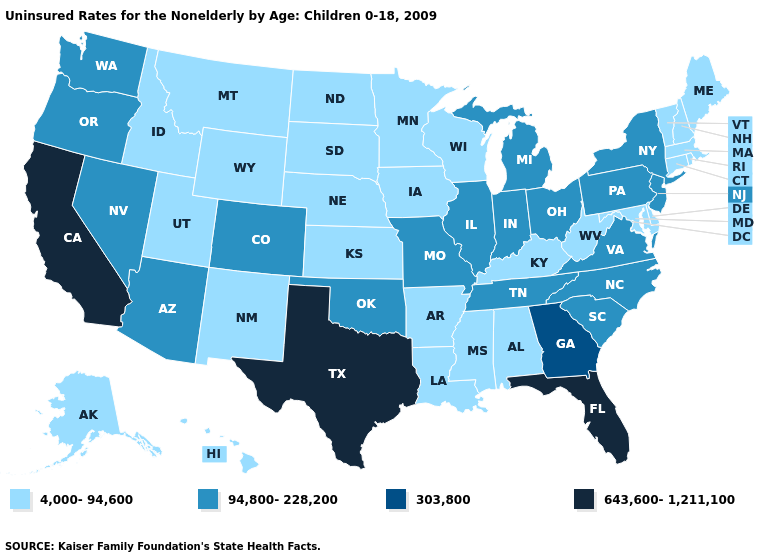What is the value of Florida?
Answer briefly. 643,600-1,211,100. Does the map have missing data?
Give a very brief answer. No. Name the states that have a value in the range 643,600-1,211,100?
Quick response, please. California, Florida, Texas. Does West Virginia have the same value as Indiana?
Give a very brief answer. No. Does Connecticut have a lower value than Missouri?
Concise answer only. Yes. Does New Hampshire have a lower value than New Mexico?
Concise answer only. No. What is the value of Iowa?
Give a very brief answer. 4,000-94,600. Does Connecticut have the lowest value in the Northeast?
Short answer required. Yes. What is the highest value in the USA?
Short answer required. 643,600-1,211,100. Which states have the lowest value in the USA?
Be succinct. Alabama, Alaska, Arkansas, Connecticut, Delaware, Hawaii, Idaho, Iowa, Kansas, Kentucky, Louisiana, Maine, Maryland, Massachusetts, Minnesota, Mississippi, Montana, Nebraska, New Hampshire, New Mexico, North Dakota, Rhode Island, South Dakota, Utah, Vermont, West Virginia, Wisconsin, Wyoming. Name the states that have a value in the range 643,600-1,211,100?
Give a very brief answer. California, Florida, Texas. Does Illinois have the lowest value in the USA?
Be succinct. No. What is the value of Rhode Island?
Be succinct. 4,000-94,600. Name the states that have a value in the range 643,600-1,211,100?
Keep it brief. California, Florida, Texas. Does Maryland have a higher value than South Carolina?
Be succinct. No. 